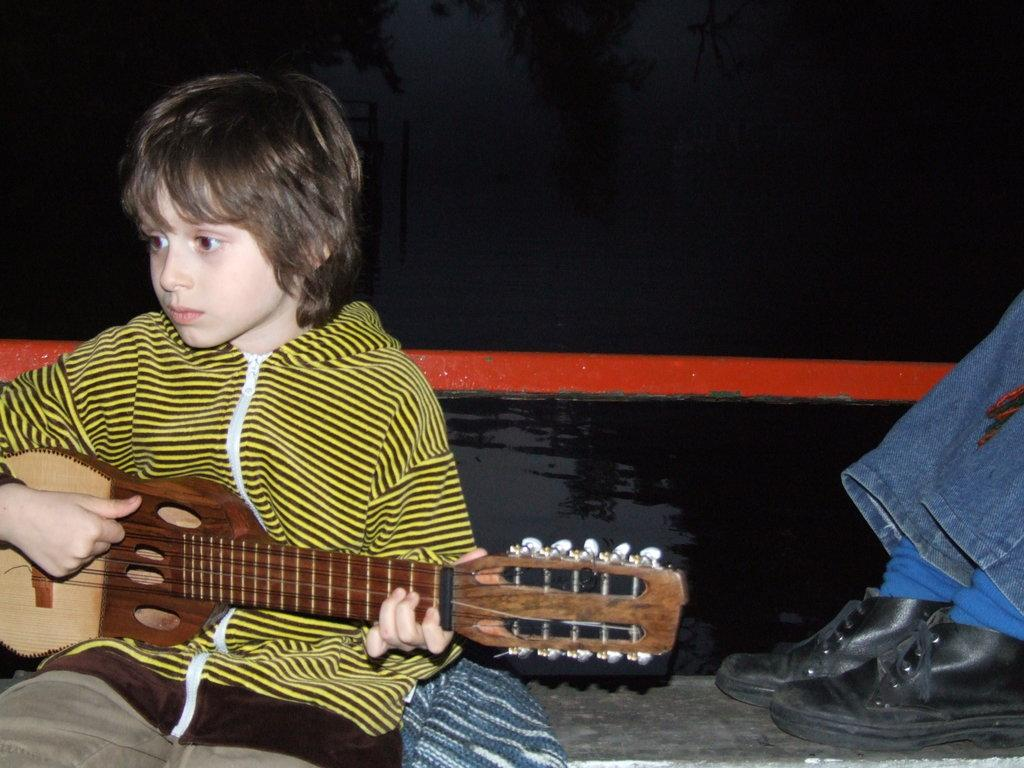Who is the main subject in the image? There is a boy in the image. What is the boy doing in the image? The boy is sitting on cloth and playing a guitar. Can you describe the surroundings of the boy? There is a person's legs visible behind the boy, and there is some water in the image. What type of curtain can be seen hanging behind the boy in the image? There is no curtain visible in the image. 